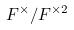<formula> <loc_0><loc_0><loc_500><loc_500>F ^ { \times } / F ^ { \times 2 }</formula> 